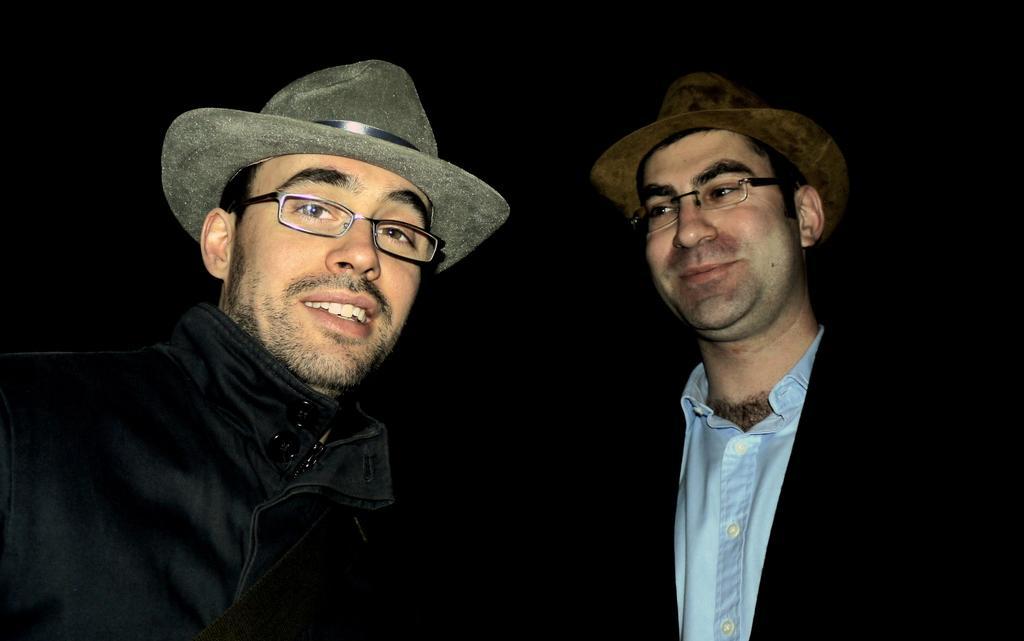How would you summarize this image in a sentence or two? In this picture I can see couple of men, they are wearing hats and spectacles and I can see dark background. 